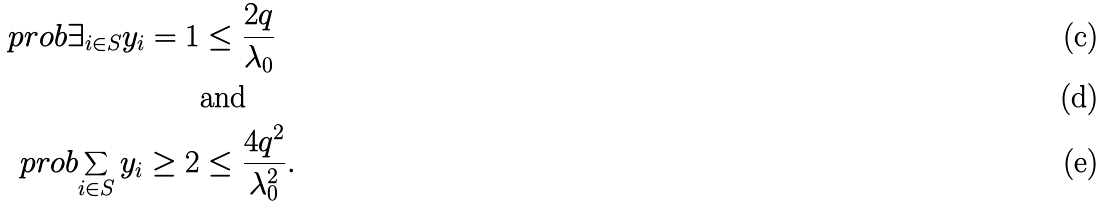<formula> <loc_0><loc_0><loc_500><loc_500>\ p r o b { \exists _ { i \in S } y _ { i } = 1 } & \leq \frac { 2 q } { \lambda _ { 0 } } \\ & \text {and} \\ \ p r o b { \sum _ { i \in S } y _ { i } \geq 2 } & \leq \frac { 4 q ^ { 2 } } { \lambda _ { 0 } ^ { 2 } } .</formula> 